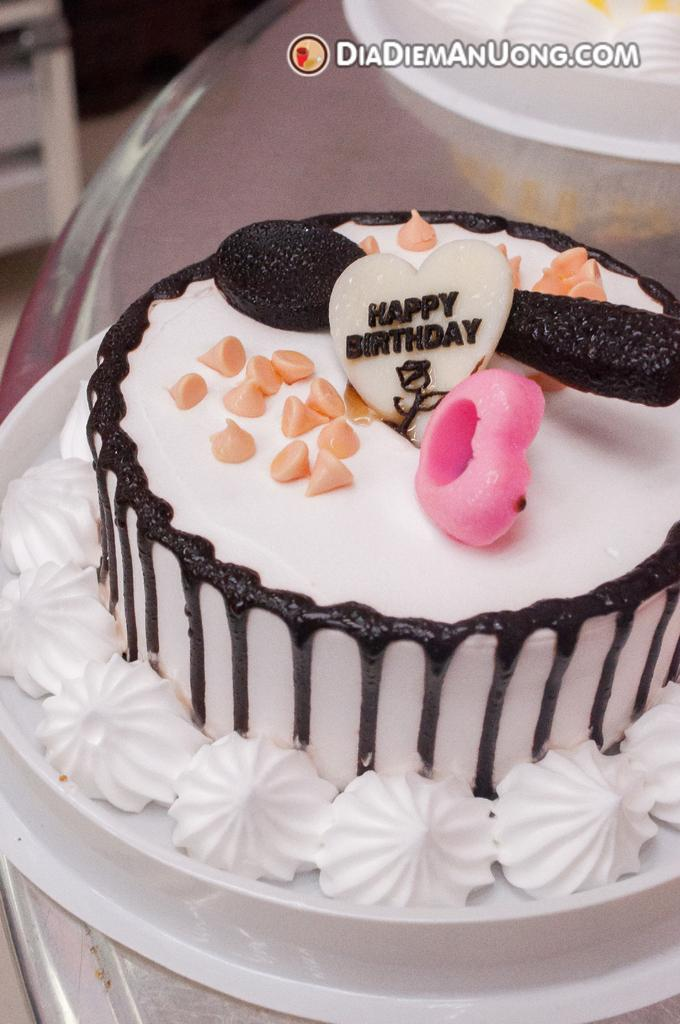How many cakes are visible in the image? There are two cakes in the image. Where are the cakes located? The cakes are on a table. What type of suit is the tramp wearing while standing near the farm in the image? There is no tramp, suit, or farm present in the image; it only features two cakes on a table. 